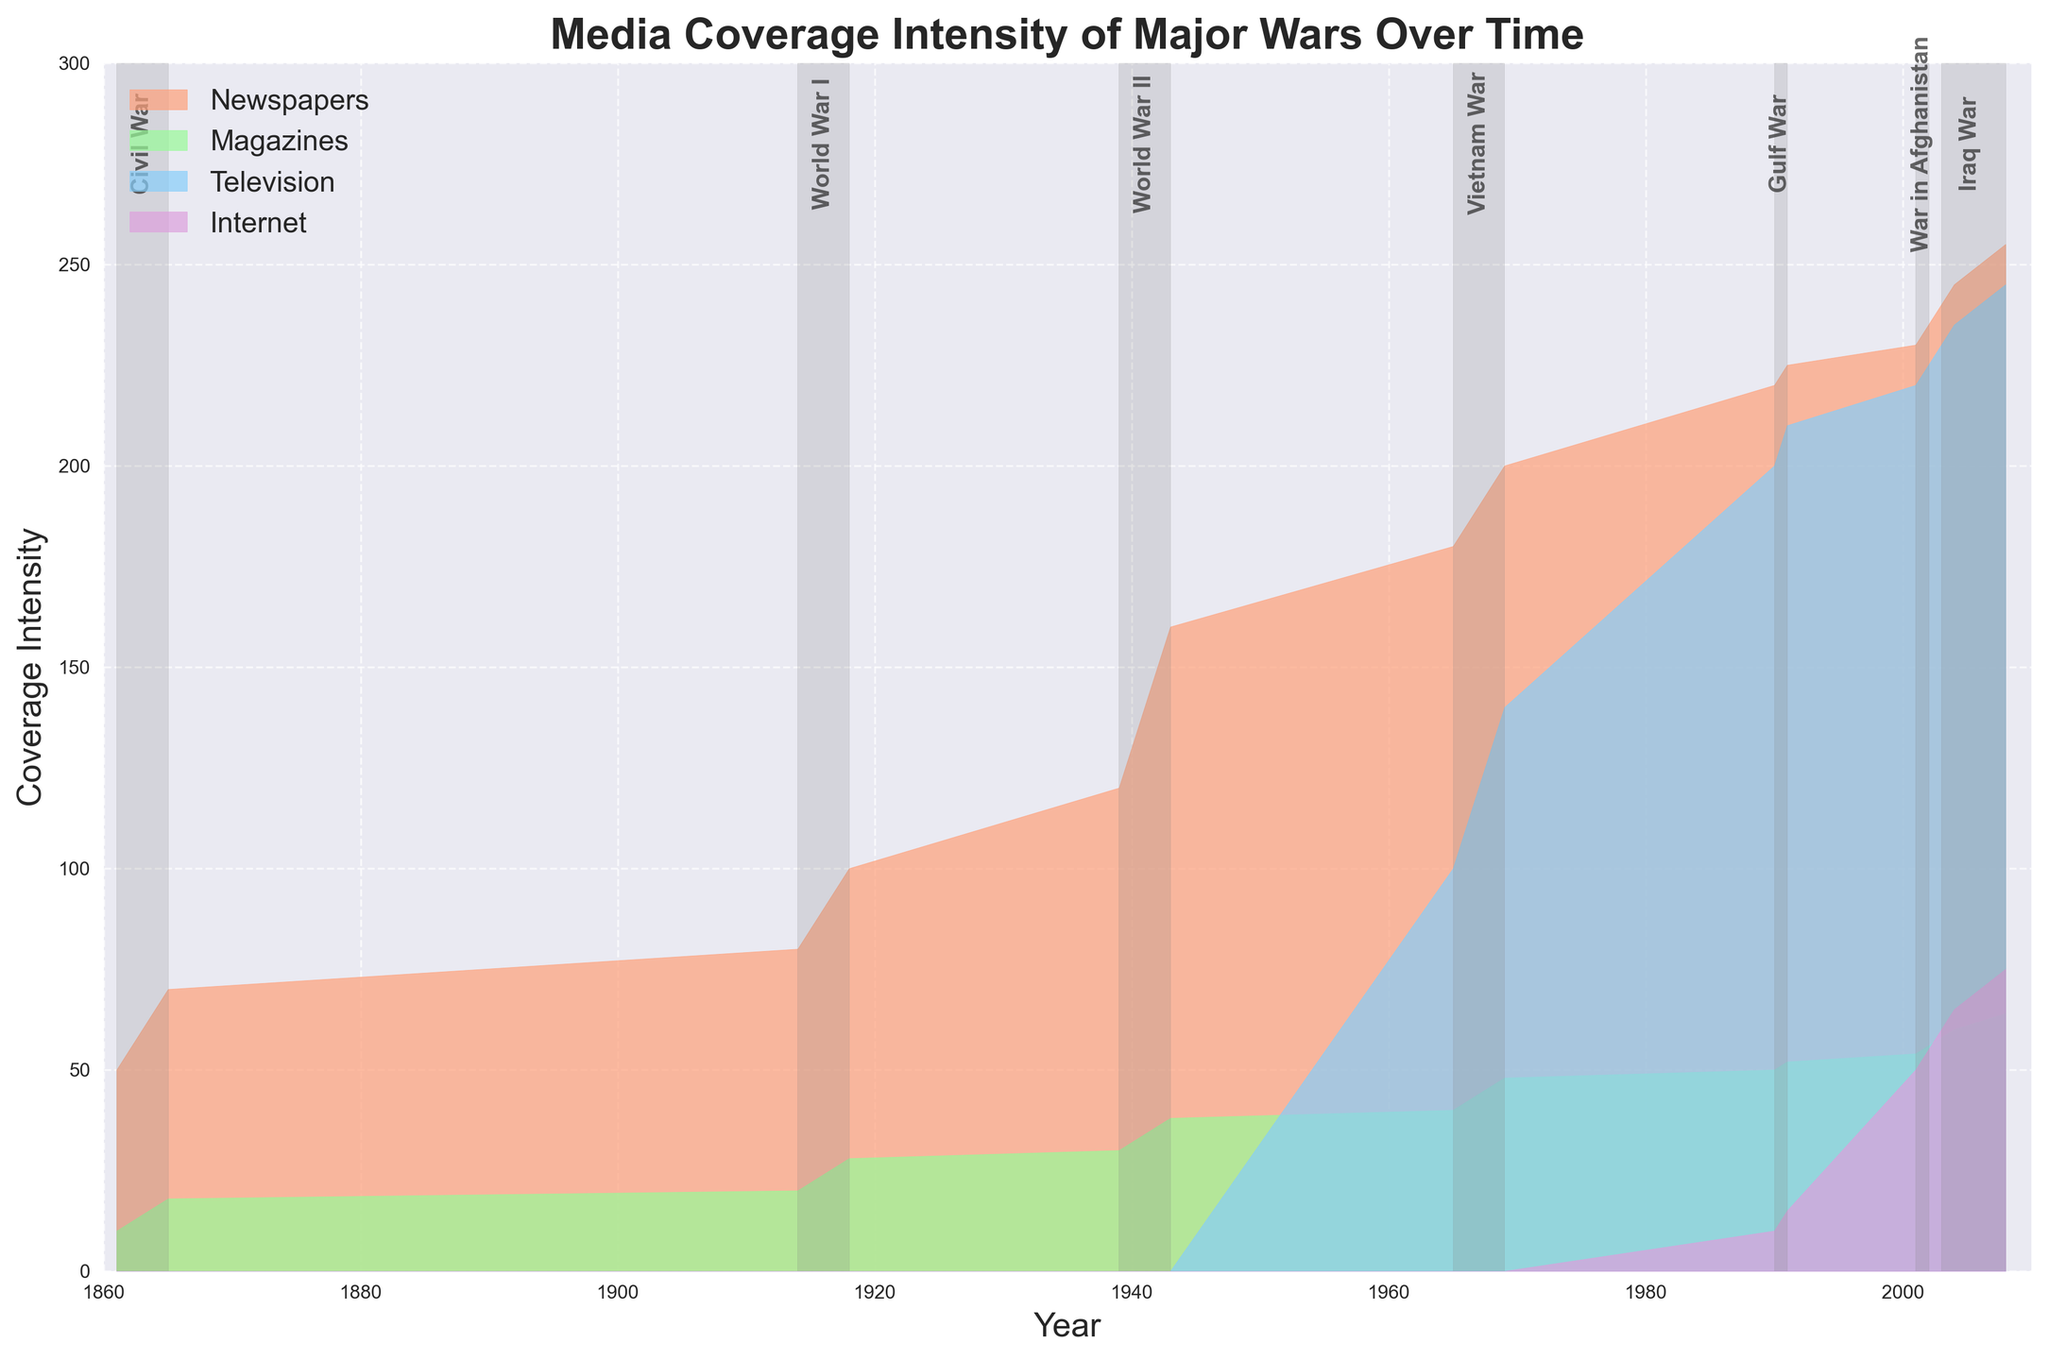What is the title of the figure? The title of the figure is the text displayed at the top of the chart, which gives a summary of what the figure represents.
Answer: Media Coverage Intensity of Major Wars Over Time How does the intensity of newspaper coverage change during the Civil War? To answer this, look at the area corresponding to 'Newspapers' between the years 1861 to 1865. Notice the pattern of increase.
Answer: It increases from 50 to 70 Which forms of media covered the Vietnam War? Look at the time period labeled as Vietnam War (1965-1969) and identify all the segments represented by different colors in that timeframe.
Answer: Newspapers, Magazines, and Television What color represents Internet coverage? Look at the label legend section of the figure and identify the area filled with colors.
Answer: Purple During which war does television coverage first appear in the chart? Find the first appearance of television coverage by locating the color representing Television (blue) along the timeline.
Answer: Vietnam War How did the intensity of magazine coverage change from World War I to World War II? Compare the height of the area representing 'Magazines' during World War I (1914-1918) and World War II (1939-1943). Note the increase of values.
Answer: It increased from 20-28 to 30-38 What is the highest coverage intensity for the Gulf War across all media forms? Identify the maximum height of the stacked areas in the section marked as Gulf War (1990-1991).
Answer: 285 Which war has the most diverse media coverage, and how can you tell? Find the war period that has the most different media forms with significant coverage, by assessing the segments in the figure.
Answer: Iraq War, as it has significant coverage in Newspapers, Magazines, Television, and Internet What trend do you see in television coverage intensity from the Vietnam War to the Iraq War? Look at the height of the television area from Vietnam War (1965-1969), Gulf War (1990-1991), War in Afghanistan (2001-2002), and Iraq War (2003-2008). Notice the pattern of increase.
Answer: It increases consistently How was media coverage split between Newspapers and Internet during the Iraq War's peak year? Observe the total area heights of Newspapers and Internet for peak intensity during the Iraq War (2008).
Answer: Newspapers: 255, Internet: 75 